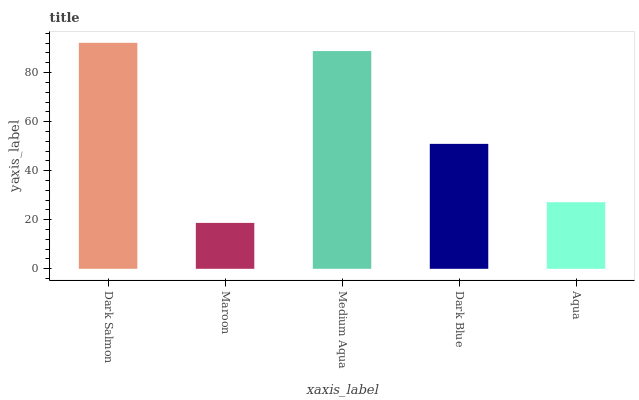Is Maroon the minimum?
Answer yes or no. Yes. Is Dark Salmon the maximum?
Answer yes or no. Yes. Is Medium Aqua the minimum?
Answer yes or no. No. Is Medium Aqua the maximum?
Answer yes or no. No. Is Medium Aqua greater than Maroon?
Answer yes or no. Yes. Is Maroon less than Medium Aqua?
Answer yes or no. Yes. Is Maroon greater than Medium Aqua?
Answer yes or no. No. Is Medium Aqua less than Maroon?
Answer yes or no. No. Is Dark Blue the high median?
Answer yes or no. Yes. Is Dark Blue the low median?
Answer yes or no. Yes. Is Dark Salmon the high median?
Answer yes or no. No. Is Aqua the low median?
Answer yes or no. No. 